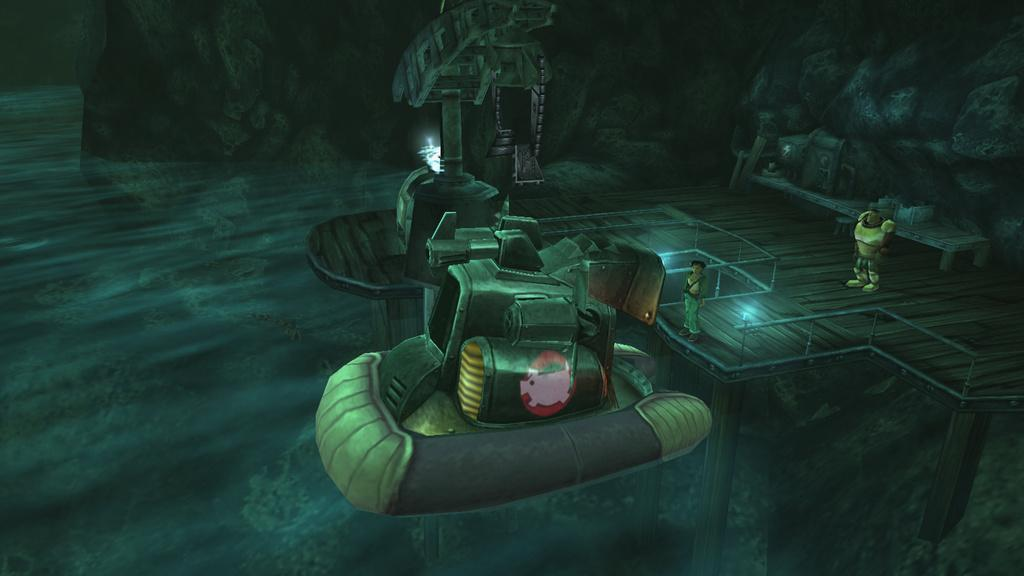How many toys can be seen in the image? There are two toys in the image. What else is present in the image besides the toys? There are rocks, machines, a walkway, and lights in the image. Where are the machines located in the image? The machines are in the center of the image. What can be found on the right side of the image? There is a walkway and lights on the right side of the image. How many cakes are being pushed by the machines in the image? There are no cakes or machines pushing cakes present in the image. What is the concentration of the elements in the image in terms of cent? The facts provided do not include any information about the concentration of elements in the image, nor does the concept of "cent" apply to the image. 